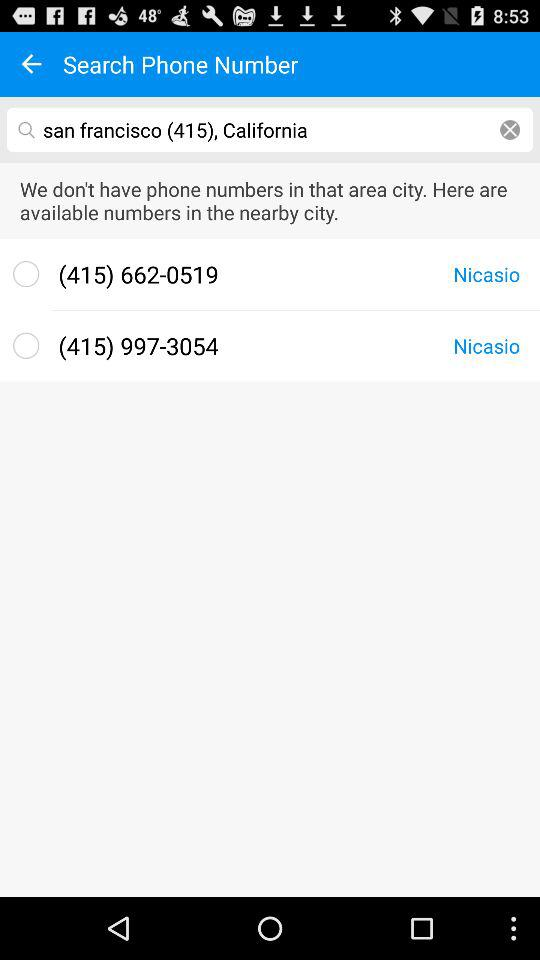What location is selected? The selected location is "san francisco (415), California". 